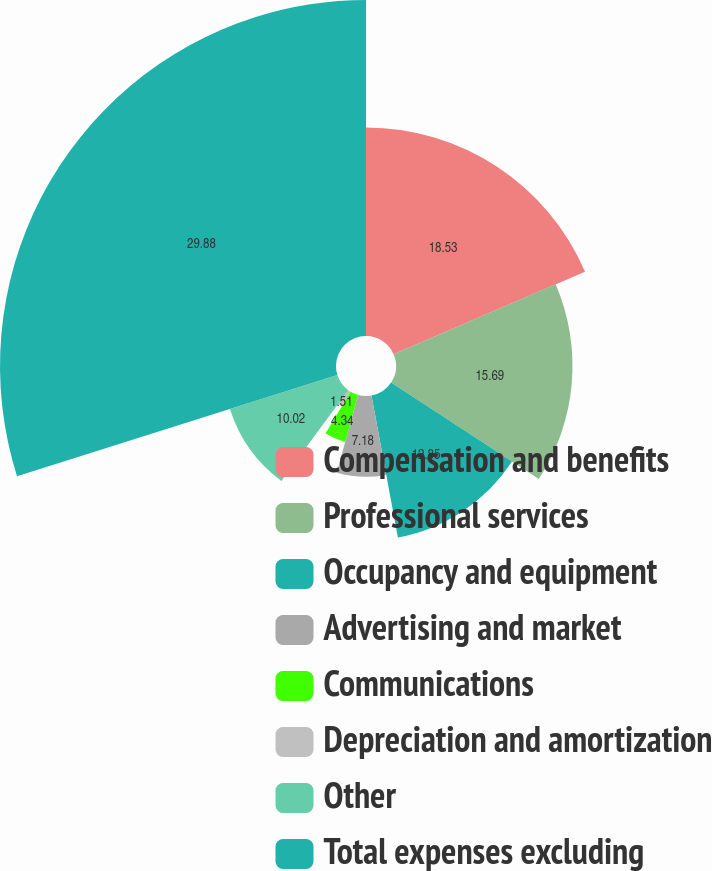<chart> <loc_0><loc_0><loc_500><loc_500><pie_chart><fcel>Compensation and benefits<fcel>Professional services<fcel>Occupancy and equipment<fcel>Advertising and market<fcel>Communications<fcel>Depreciation and amortization<fcel>Other<fcel>Total expenses excluding<nl><fcel>18.53%<fcel>15.69%<fcel>12.85%<fcel>7.18%<fcel>4.34%<fcel>1.51%<fcel>10.02%<fcel>29.87%<nl></chart> 